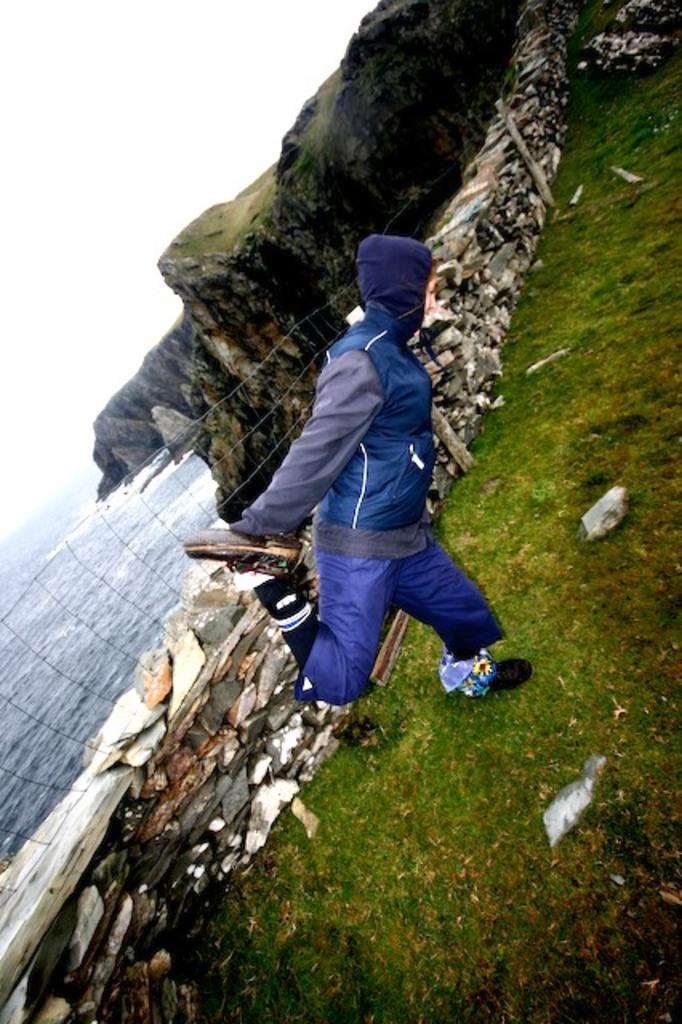How would you summarize this image in a sentence or two? In this image we can see a person wearing a blue color jacket. At the bottom of the image there is grass. In the background of the image there are mountains, water. At the top of the image there is sky. 